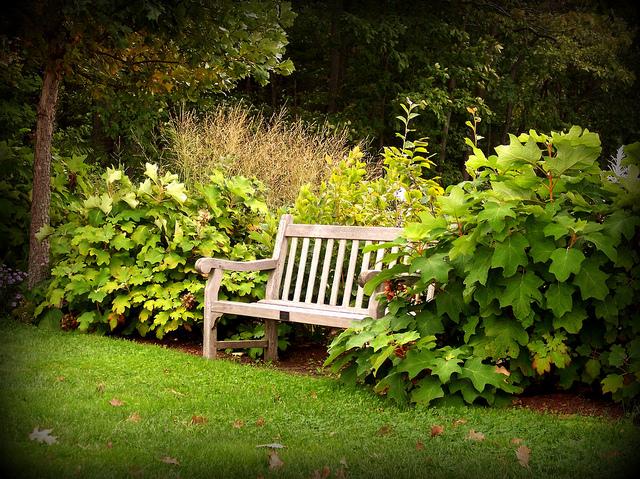What number of boards is the bench made from?
Give a very brief answer. 10. Do the bushes on each side of the bench match?
Keep it brief. Yes. Is the plant trying to hug the bench?
Keep it brief. No. Are these pale leafy greens edible for humans?
Concise answer only. No. Was this photo taken during the day?
Answer briefly. Yes. What season is it?
Answer briefly. Spring. How many people can sit on the bench at once?
Answer briefly. 3. What color is the bush?
Concise answer only. Green. 